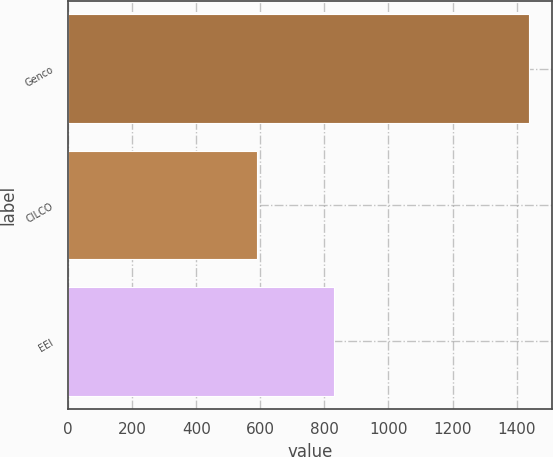<chart> <loc_0><loc_0><loc_500><loc_500><bar_chart><fcel>Genco<fcel>CILCO<fcel>EEI<nl><fcel>1440<fcel>590<fcel>830<nl></chart> 